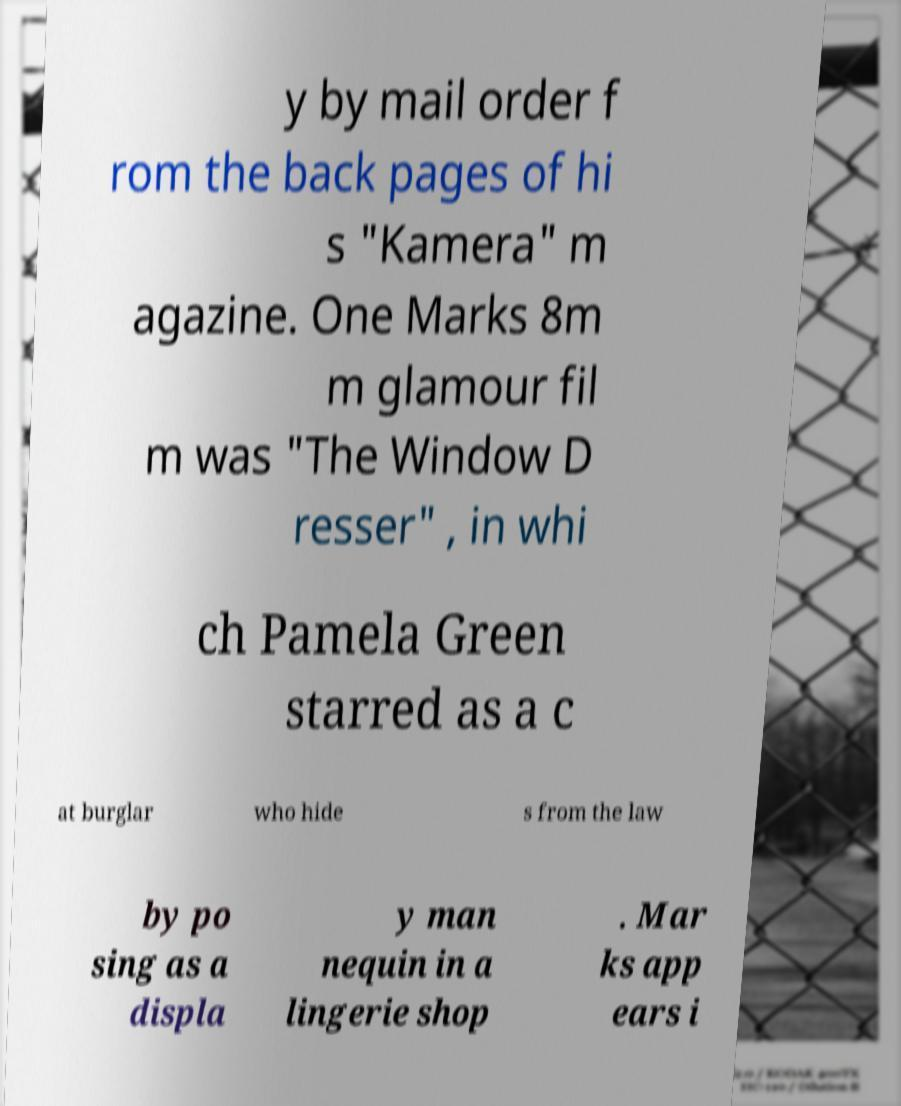Could you assist in decoding the text presented in this image and type it out clearly? y by mail order f rom the back pages of hi s "Kamera" m agazine. One Marks 8m m glamour fil m was "The Window D resser" , in whi ch Pamela Green starred as a c at burglar who hide s from the law by po sing as a displa y man nequin in a lingerie shop . Mar ks app ears i 